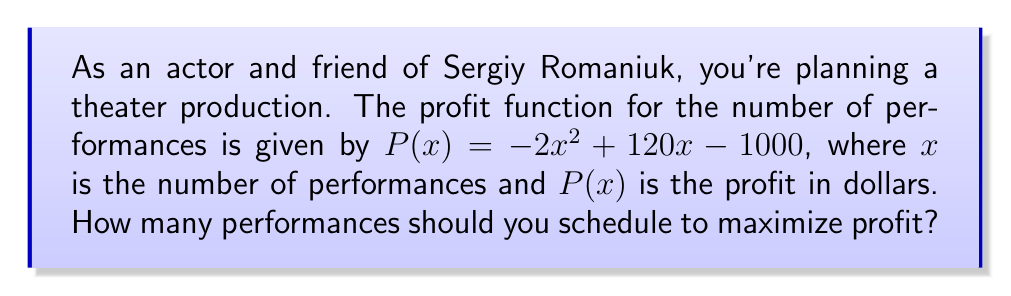Can you answer this question? To find the optimal number of performances that maximizes profit, we need to follow these steps:

1) The profit function $P(x) = -2x^2 + 120x - 1000$ is a quadratic function. Its graph is a parabola that opens downward because the coefficient of $x^2$ is negative.

2) The maximum point of a parabola occurs at the vertex. For a quadratic function in the form $f(x) = ax^2 + bx + c$, the x-coordinate of the vertex is given by $x = -\frac{b}{2a}$.

3) In our case, $a = -2$, $b = 120$, and $c = -1000$. Let's substitute these values:

   $x = -\frac{120}{2(-2)} = -\frac{120}{-4} = 30$

4) To verify this is a maximum (not a minimum), we can check that the parabola opens downward ($a < 0$) or calculate the second derivative ($P''(x) = -4 < 0$).

5) Therefore, the profit is maximized when $x = 30$ performances are scheduled.

6) We can calculate the maximum profit by substituting $x = 30$ into the original function:

   $P(30) = -2(30)^2 + 120(30) - 1000$
          $= -1800 + 3600 - 1000$
          $= 800$

So, the maximum profit is $800 when 30 performances are scheduled.
Answer: 30 performances 